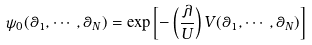<formula> <loc_0><loc_0><loc_500><loc_500>\psi _ { 0 } ( \theta _ { 1 } , \cdots , \theta _ { N } ) = \exp { \left [ - \left ( \frac { \lambda } { U } \right ) V ( \theta _ { 1 } , \cdots , \theta _ { N } ) \right ] }</formula> 